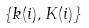Convert formula to latex. <formula><loc_0><loc_0><loc_500><loc_500>\{ k ( i ) , K ( i ) \}</formula> 